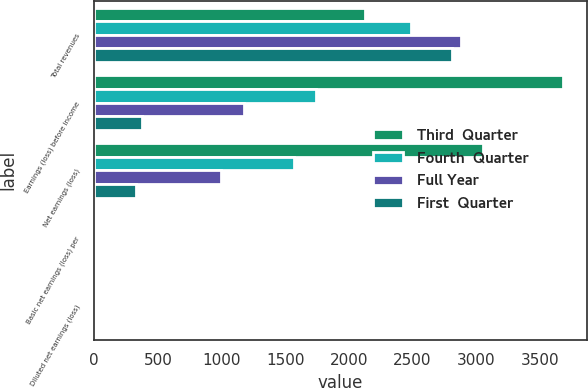Convert chart to OTSL. <chart><loc_0><loc_0><loc_500><loc_500><stacked_bar_chart><ecel><fcel>Total revenues<fcel>Earnings (loss) before income<fcel>Net earnings (loss)<fcel>Basic net earnings (loss) per<fcel>Diluted net earnings (loss)<nl><fcel>Third  Quarter<fcel>2126<fcel>3685<fcel>3056<fcel>6.44<fcel>6.44<nl><fcel>Fourth  Quarter<fcel>2488<fcel>1745<fcel>1570<fcel>3.04<fcel>3.04<nl><fcel>Full Year<fcel>2882<fcel>1178<fcel>993<fcel>1.9<fcel>1.89<nl><fcel>First  Quarter<fcel>2808<fcel>375<fcel>331<fcel>0.63<fcel>0.63<nl></chart> 